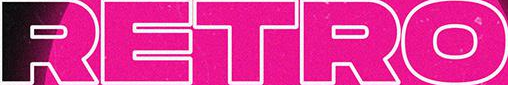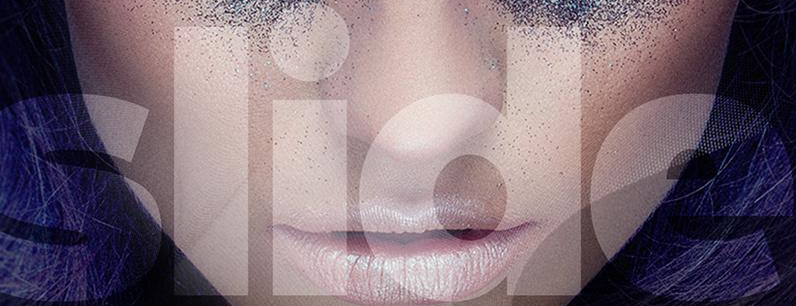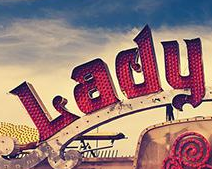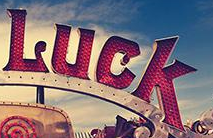What words can you see in these images in sequence, separated by a semicolon? RETRO; slide; Lady; Luck 